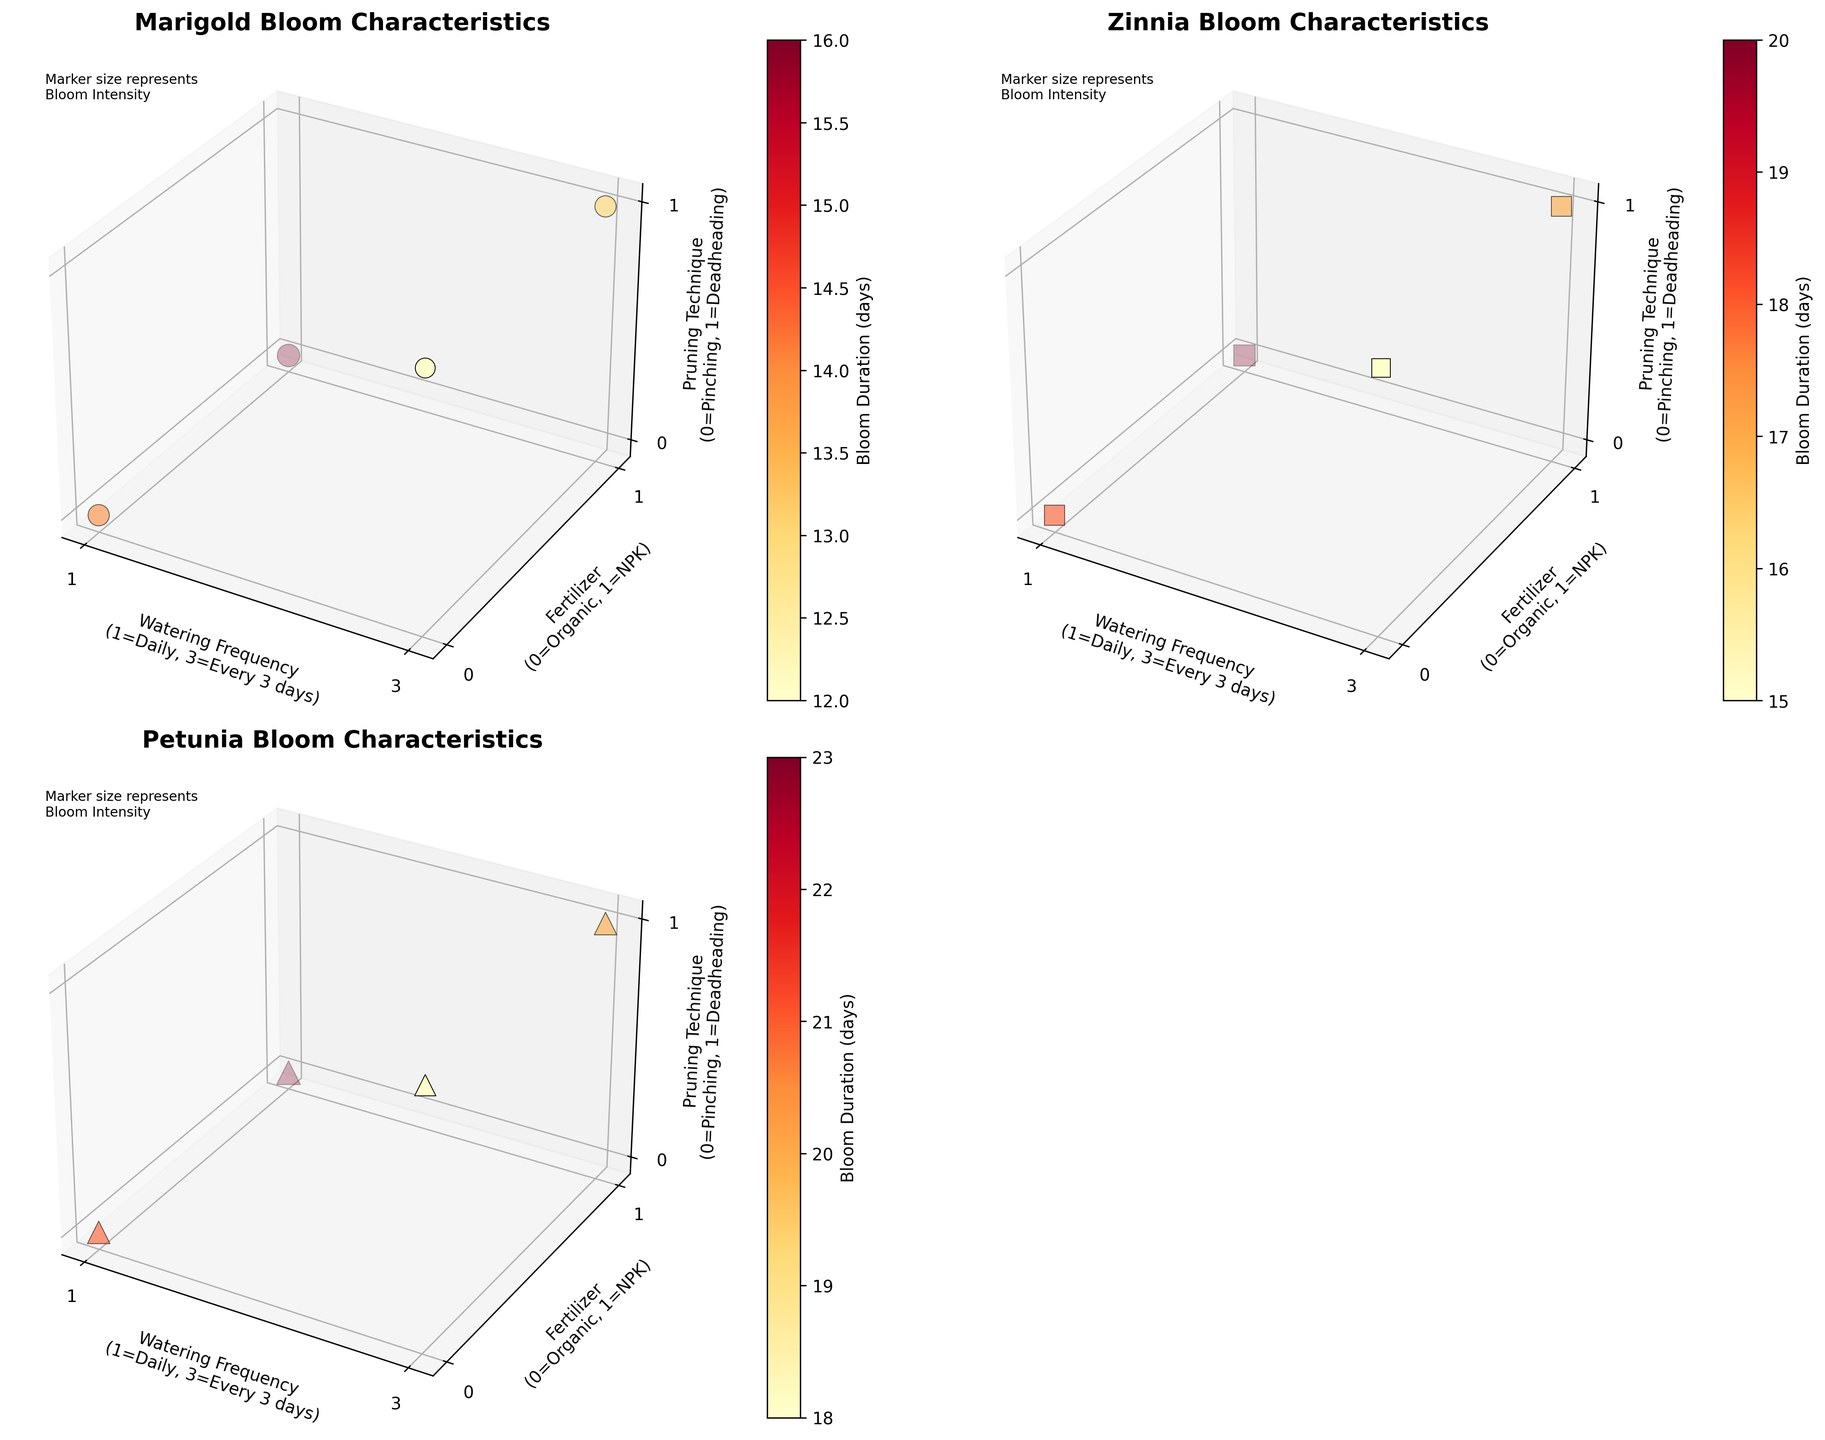What are the axes labels for the plot of Marigold bloom characteristics? The Marigold plot's axes are labeled as follows: the x-axis is "Watering Frequency" with values (1=Daily, 3=Every 3 days). The y-axis is "Fertilizer" with values (0=Organic, 1=NPK). The z-axis is "Pruning Technique" with values (0=Pinching, 1=Deadheading).
Answer: "Watering Frequency", "Fertilizer", "Pruning Technique" How does the Bloom Duration for Marigold change with different fertilizers when the watering frequency is daily? For Marigold under daily watering, the Bloom Duration is 14 days with Organic Compost and 16 days with NPK 5-5-5. So, the duration increases when switching from Organic Compost to NPK 5-5-5.
Answer: Increases Which species shows the highest Bloom Intensity for daily watering, NPK 5-5-5 fertilizer, and pinching technique? Among the species, Petunia shows the highest Bloom Intensity with a value of 10 under daily watering, NPK 5-5-5 fertilizer, and pinching technique.
Answer: Petunia For Zinnia, how does the Bloom Duration vary between the two pruning techniques when using NPK 5-5-5 fertilizer and watering every 3 days? When using NPK 5-5-5 fertilizer and watering every 3 days, the Bloom Duration for Zinnia is 20 days with pinching and 17 days with deadheading, showing a decrease.
Answer: Decrease Compare the Bloom Intensity of Petunia under daily watering, using Organic Compost, and pinching versus using NPK 5-5-5 and deadheading every 3 days. For Petunia, the Bloom Intensity is 9 with Organic Compost, daily watering, and pinching, while it is 9 with NPK 5-5-5, every 3 days watering, and deadheading. Thus, the intensity is the same.
Answer: Same What is the marker size representing the highest Bloom Intensity and for which species and conditions does it occur? The largest marker size (which represents a Bloom Intensity of 10) appears for Petunia under the conditions of daily watering, NPK 5-5-5 fertilizer, and pinching technique.
Answer: Petunia, daily watering, NPK 5-5-5, pinching Under which watering frequency and fertilizer type does Zinnia have a maximum Bloom Duration? Zinnia has the maximum Bloom Duration of 20 days under daily watering with NPK 5-5-5 fertilizer.
Answer: Daily watering, NPK 5-5-5 For Marigold, how do the Bloom Durations compare between the pinching technique and deadheading when watering is done every 3 days using Organic Compost? For Marigold, with watering every 3 days using Organic Compost, the Bloom Duration is 12 days with deadheading and 11 days with pinching, so the duration is shorter with pinching.
Answer: Shorter with pinching 